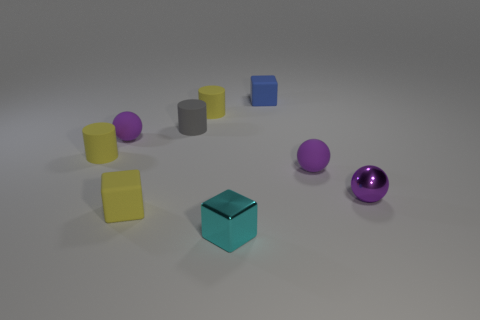What colors are represented in the objects, and do any colors appear more than once? The objects showcase a variety of colors including blue, yellow, purple, gray, and a metallic sheen. Yellow appears twice in the form of two different cylindrical objects. Are the yellow objects the same shade of yellow? No, upon closer inspection, one yellow cylinder has a slightly brighter hue compared to the other. 